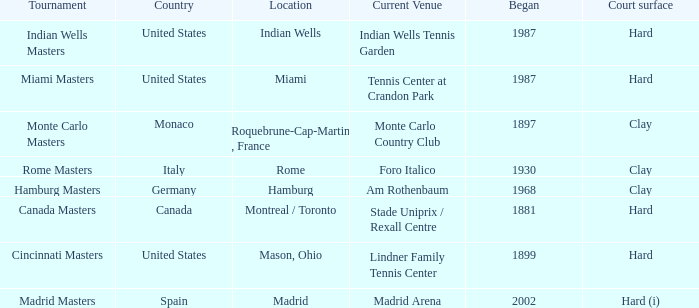How many tourneys are currently held at the lindner family tennis center? 1.0. 